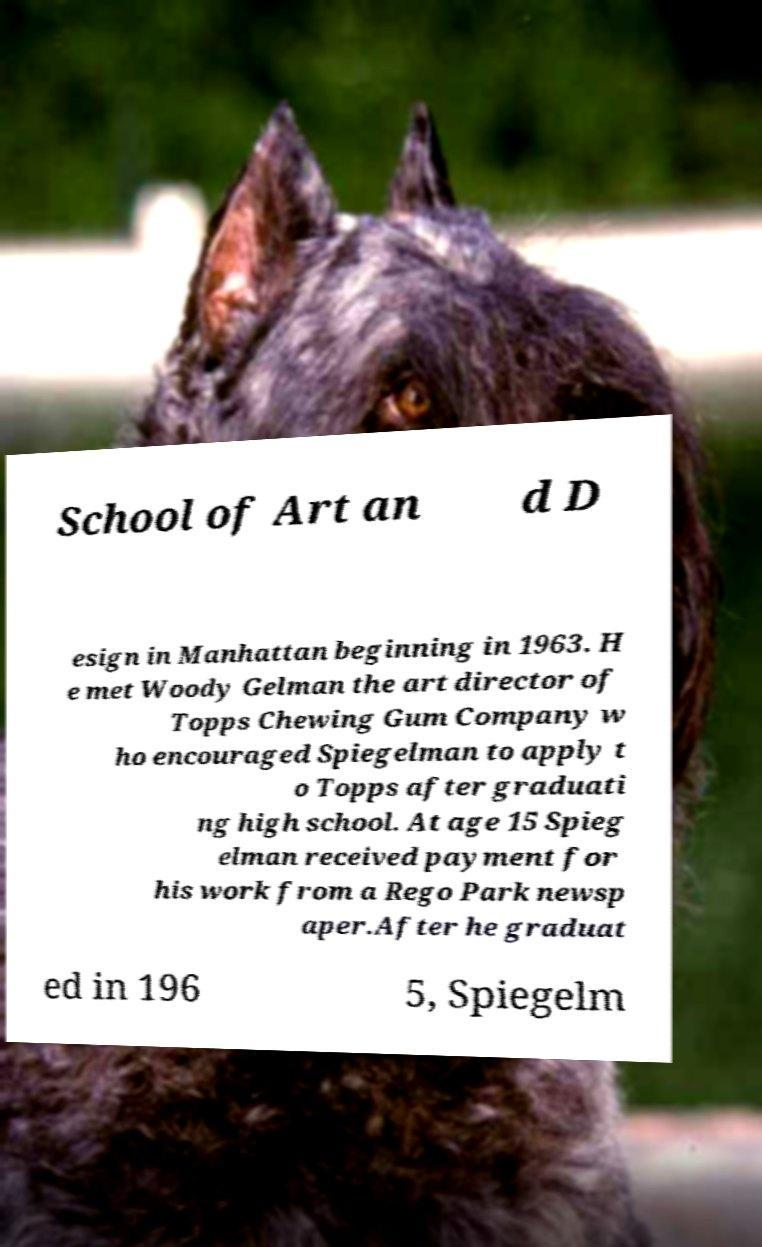Can you accurately transcribe the text from the provided image for me? School of Art an d D esign in Manhattan beginning in 1963. H e met Woody Gelman the art director of Topps Chewing Gum Company w ho encouraged Spiegelman to apply t o Topps after graduati ng high school. At age 15 Spieg elman received payment for his work from a Rego Park newsp aper.After he graduat ed in 196 5, Spiegelm 